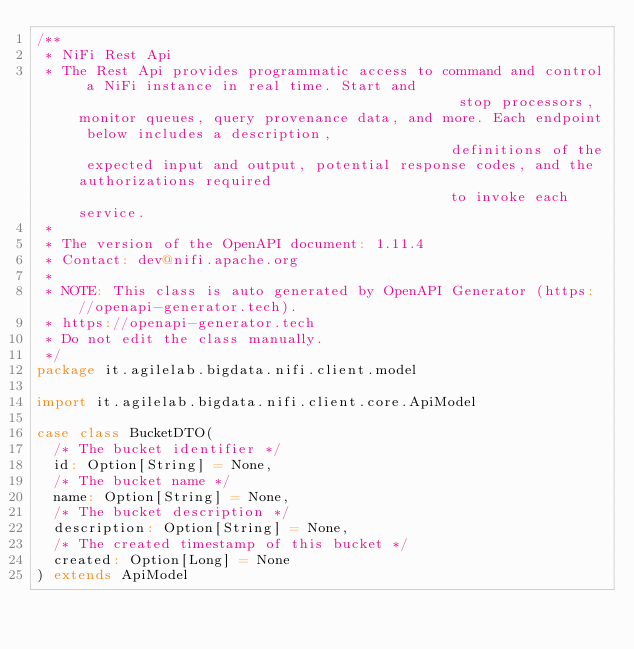<code> <loc_0><loc_0><loc_500><loc_500><_Scala_>/**
 * NiFi Rest Api
 * The Rest Api provides programmatic access to command and control a NiFi instance in real time. Start and                                              stop processors, monitor queues, query provenance data, and more. Each endpoint below includes a description,                                             definitions of the expected input and output, potential response codes, and the authorizations required                                             to invoke each service.
 *
 * The version of the OpenAPI document: 1.11.4
 * Contact: dev@nifi.apache.org
 *
 * NOTE: This class is auto generated by OpenAPI Generator (https://openapi-generator.tech).
 * https://openapi-generator.tech
 * Do not edit the class manually.
 */
package it.agilelab.bigdata.nifi.client.model

import it.agilelab.bigdata.nifi.client.core.ApiModel

case class BucketDTO(
  /* The bucket identifier */
  id: Option[String] = None,
  /* The bucket name */
  name: Option[String] = None,
  /* The bucket description */
  description: Option[String] = None,
  /* The created timestamp of this bucket */
  created: Option[Long] = None
) extends ApiModel


</code> 